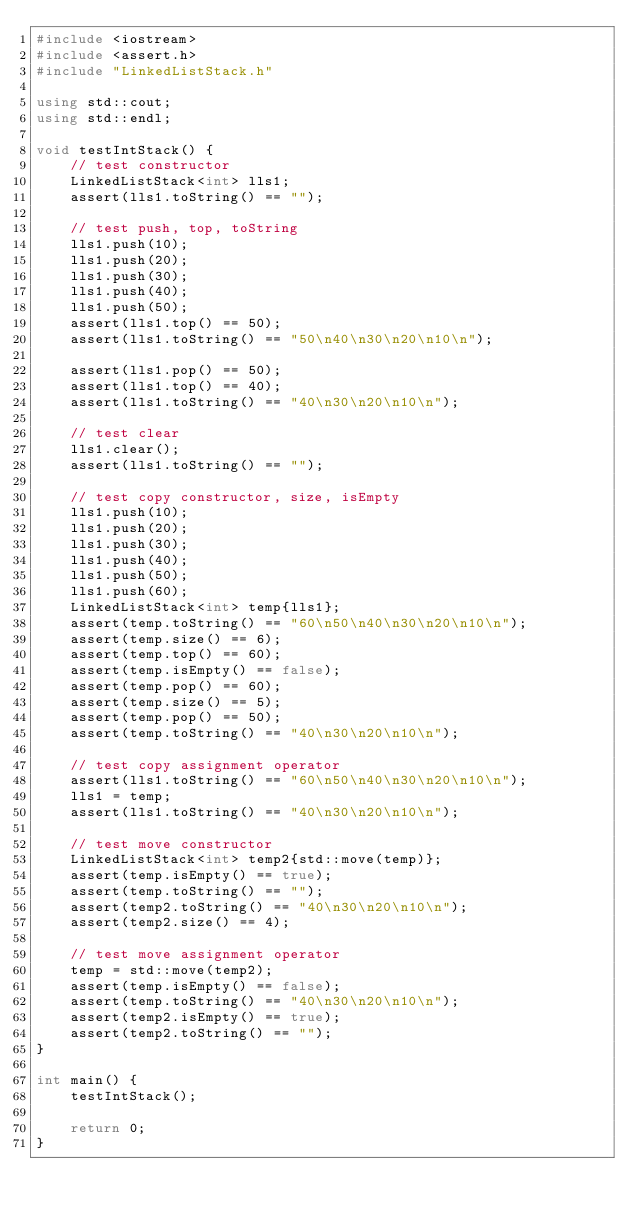<code> <loc_0><loc_0><loc_500><loc_500><_C++_>#include <iostream>
#include <assert.h>
#include "LinkedListStack.h"

using std::cout;
using std::endl;

void testIntStack() {
    // test constructor
    LinkedListStack<int> lls1;
    assert(lls1.toString() == "");

    // test push, top, toString
    lls1.push(10);
    lls1.push(20);
    lls1.push(30);
    lls1.push(40);
    lls1.push(50);
    assert(lls1.top() == 50);
    assert(lls1.toString() == "50\n40\n30\n20\n10\n");

    assert(lls1.pop() == 50);
    assert(lls1.top() == 40);
    assert(lls1.toString() == "40\n30\n20\n10\n");

    // test clear
    lls1.clear();
    assert(lls1.toString() == "");

    // test copy constructor, size, isEmpty
    lls1.push(10);
    lls1.push(20);
    lls1.push(30);
    lls1.push(40);
    lls1.push(50);
    lls1.push(60);
    LinkedListStack<int> temp{lls1};
    assert(temp.toString() == "60\n50\n40\n30\n20\n10\n");
    assert(temp.size() == 6);
    assert(temp.top() == 60);
    assert(temp.isEmpty() == false);
    assert(temp.pop() == 60);
    assert(temp.size() == 5);
    assert(temp.pop() == 50);
    assert(temp.toString() == "40\n30\n20\n10\n");

    // test copy assignment operator
    assert(lls1.toString() == "60\n50\n40\n30\n20\n10\n");
    lls1 = temp;
    assert(lls1.toString() == "40\n30\n20\n10\n");

    // test move constructor
    LinkedListStack<int> temp2{std::move(temp)};
    assert(temp.isEmpty() == true);
    assert(temp.toString() == "");
    assert(temp2.toString() == "40\n30\n20\n10\n");
    assert(temp2.size() == 4);

    // test move assignment operator
    temp = std::move(temp2);
    assert(temp.isEmpty() == false);
    assert(temp.toString() == "40\n30\n20\n10\n");
    assert(temp2.isEmpty() == true);
    assert(temp2.toString() == "");
}

int main() {
    testIntStack();

    return 0;
}</code> 